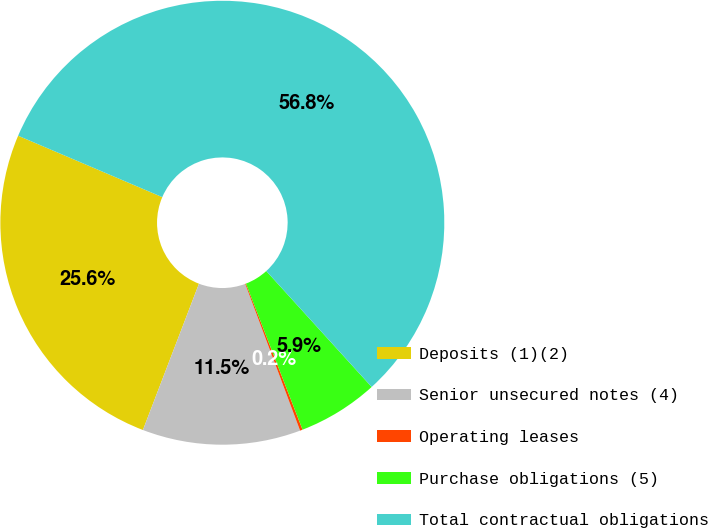Convert chart to OTSL. <chart><loc_0><loc_0><loc_500><loc_500><pie_chart><fcel>Deposits (1)(2)<fcel>Senior unsecured notes (4)<fcel>Operating leases<fcel>Purchase obligations (5)<fcel>Total contractual obligations<nl><fcel>25.59%<fcel>11.52%<fcel>0.19%<fcel>5.86%<fcel>56.85%<nl></chart> 